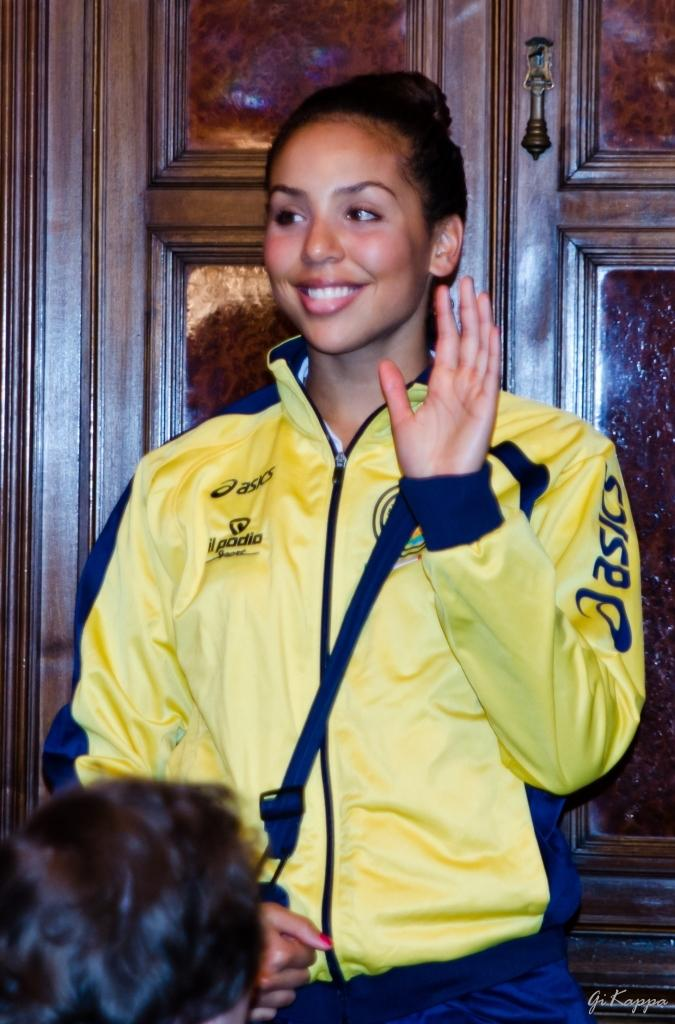<image>
Describe the image concisely. A woman wearing a pale yellow and navy blue Asics sports jacket. 